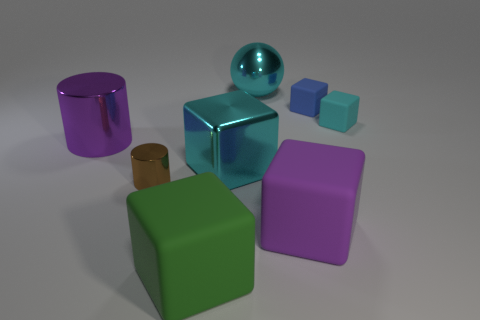Subtract all big metal blocks. How many blocks are left? 4 Subtract all green spheres. How many cyan cubes are left? 2 Subtract all green cubes. How many cubes are left? 4 Subtract 1 blocks. How many blocks are left? 4 Add 1 cyan objects. How many objects exist? 9 Subtract all purple blocks. Subtract all green balls. How many blocks are left? 4 Subtract all spheres. How many objects are left? 7 Subtract 0 yellow spheres. How many objects are left? 8 Subtract all large green blocks. Subtract all blue rubber balls. How many objects are left? 7 Add 2 purple metallic things. How many purple metallic things are left? 3 